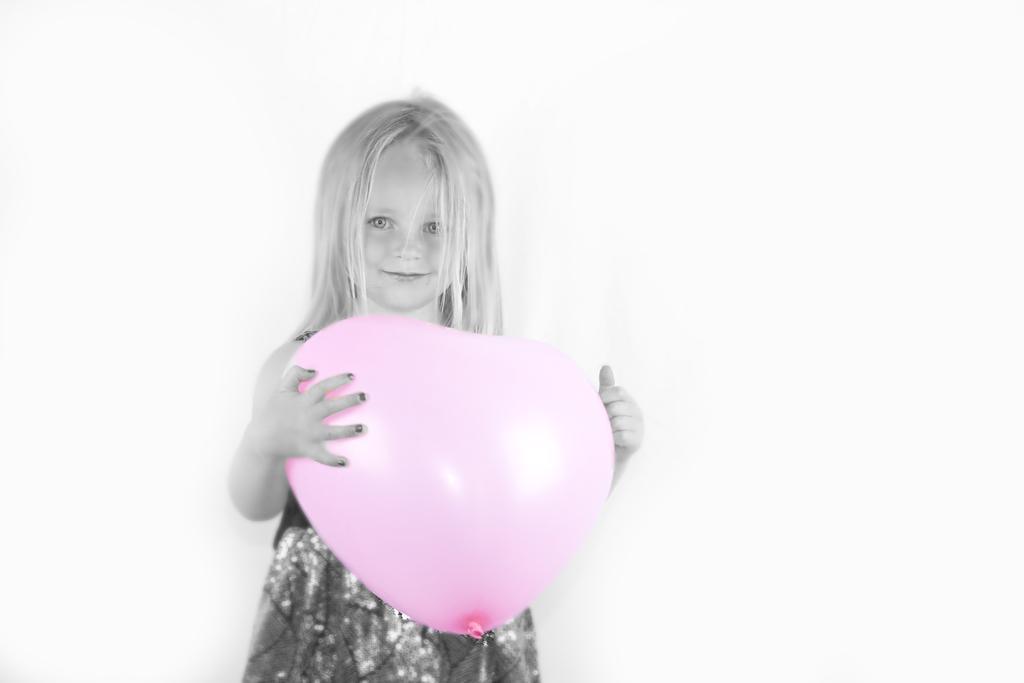How would you summarize this image in a sentence or two? In the foreground I can see a girl is holding a balloon in hand is standing. The background is white in color. This image is taken may be in a house. 